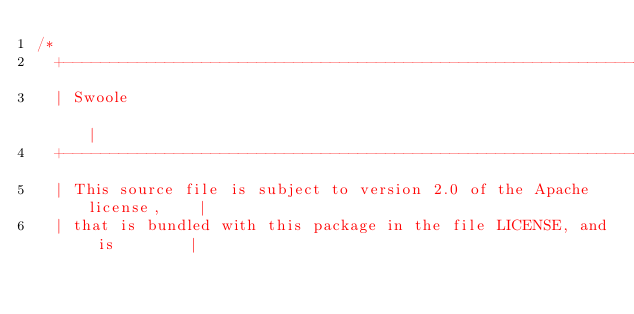Convert code to text. <code><loc_0><loc_0><loc_500><loc_500><_C++_>/*
  +----------------------------------------------------------------------+
  | Swoole                                                               |
  +----------------------------------------------------------------------+
  | This source file is subject to version 2.0 of the Apache license,    |
  | that is bundled with this package in the file LICENSE, and is        |</code> 